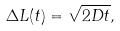Convert formula to latex. <formula><loc_0><loc_0><loc_500><loc_500>\Delta L ( t ) = \sqrt { 2 D t } ,</formula> 